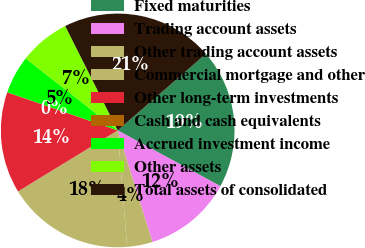<chart> <loc_0><loc_0><loc_500><loc_500><pie_chart><fcel>Fixed maturities<fcel>Trading account assets<fcel>Other trading account assets<fcel>Commercial mortgage and other<fcel>Other long-term investments<fcel>Cash and cash equivalents<fcel>Accrued investment income<fcel>Other assets<fcel>Total assets of consolidated<nl><fcel>19.29%<fcel>12.28%<fcel>3.52%<fcel>17.54%<fcel>14.03%<fcel>0.01%<fcel>5.27%<fcel>7.02%<fcel>21.04%<nl></chart> 